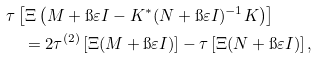Convert formula to latex. <formula><loc_0><loc_0><loc_500><loc_500>& \tau \left [ \Xi \left ( M + \i \varepsilon I - K ^ { * } ( N + \i \varepsilon I ) ^ { - 1 } K \right ) \right ] \\ & \quad = 2 \tau ^ { ( 2 ) } \left [ \Xi ( { M } + \i \varepsilon { I } ) \right ] - \tau \left [ \Xi ( N + \i \varepsilon I ) \right ] ,</formula> 